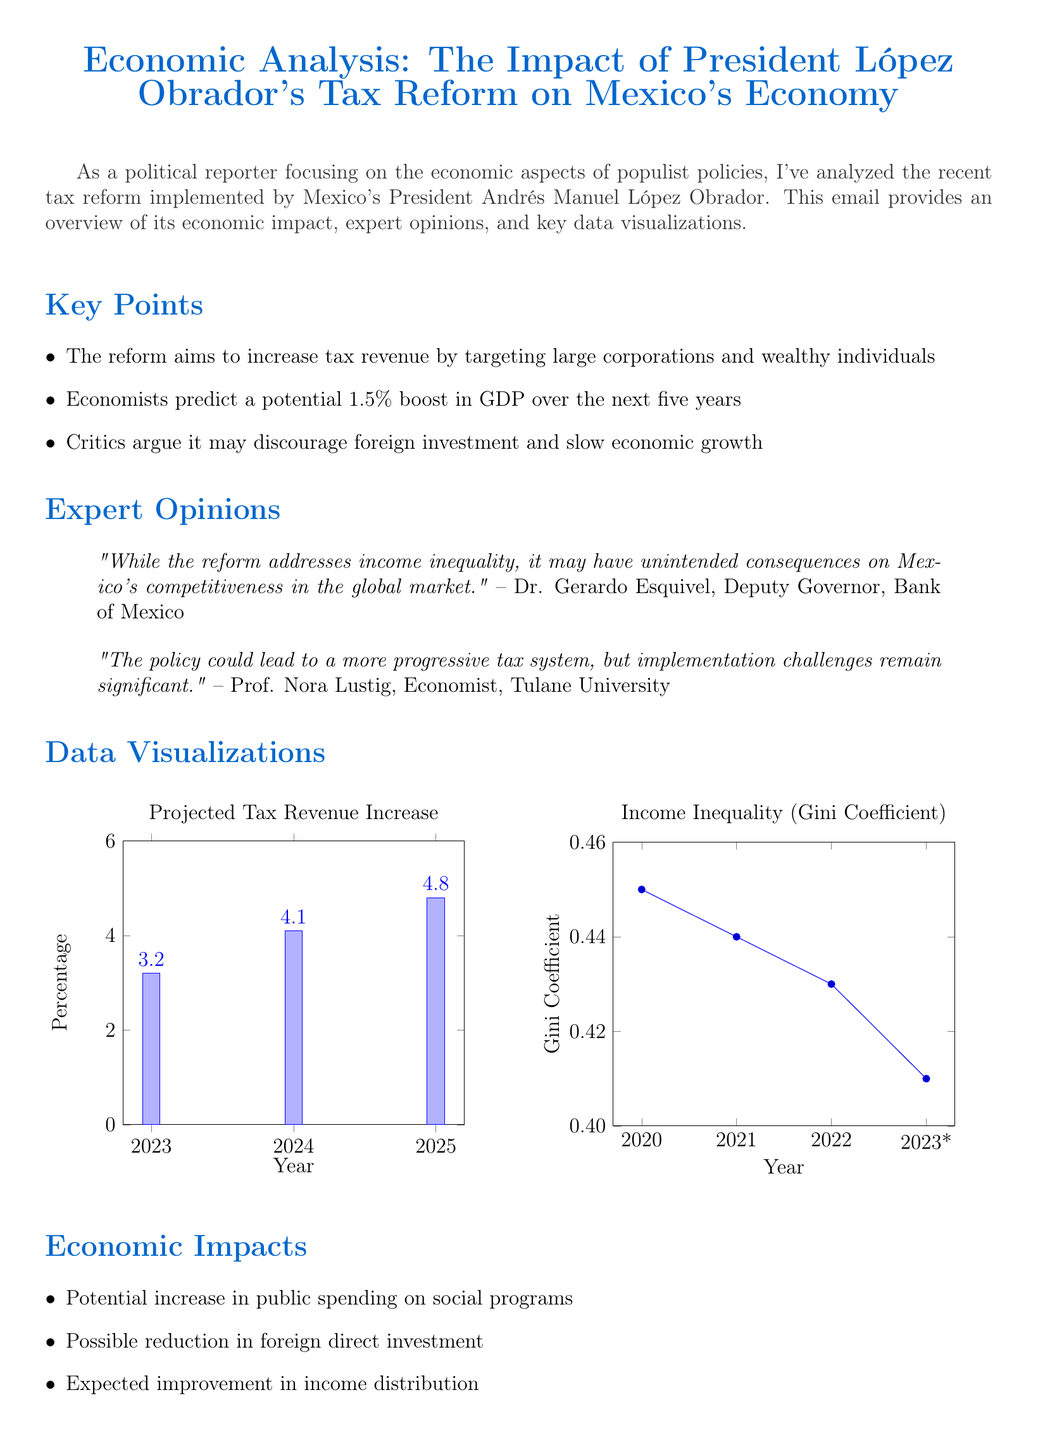What is the subject of the analysis? The subject of the analysis refers to the main topic covered in the document, which is about the economic impact of a specific tax reform by a political figure.
Answer: Economic Analysis: The Impact of President López Obrador's Tax Reform on Mexico's Economy What is the predicted GDP boost over the next five years? This refers to the economists' estimates regarding the potential impact of the tax reform on the country's economic growth measured by GDP.
Answer: 1.5% Who is the Deputy Governor of the Bank of Mexico? This question seeks to identify a key expert mentioned in the document and their title.
Answer: Dr. Gerardo Esquivel What is the Gini coefficient projected for 2023? The Gini coefficient is a measure of income inequality, and the projected value for 2023 is provided in the data visualizations section.
Answer: 0.41 Which economic aspect may be negatively affected according to critics? This question aims to find specific concerns raised by critics about potential consequences of the tax reform.
Answer: Foreign investment What are the data visualizations used in the document? This question asks for the titles of the figures presented in the document for better understanding of the data analysis.
Answer: Projected Tax Revenue Increase, Income Inequality (Gini Coefficient) What is a potential economic impact of the tax reform? This references expected outcomes of the policy as discussed in the document regarding the broader economic landscape.
Answer: Increase in public spending on social programs What did Prof. Nora Lustig comment about the tax policy? This question seeks a specific opinion provided by an expert regarding the effectiveness and challenges of the implemented tax policy.
Answer: The policy could lead to a more progressive tax system, but implementation challenges remain significant 